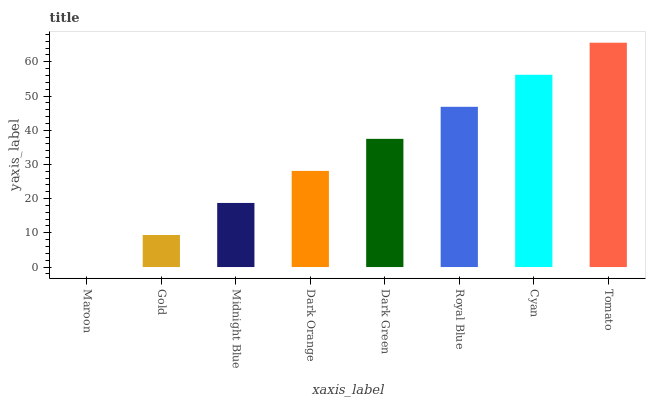Is Maroon the minimum?
Answer yes or no. Yes. Is Tomato the maximum?
Answer yes or no. Yes. Is Gold the minimum?
Answer yes or no. No. Is Gold the maximum?
Answer yes or no. No. Is Gold greater than Maroon?
Answer yes or no. Yes. Is Maroon less than Gold?
Answer yes or no. Yes. Is Maroon greater than Gold?
Answer yes or no. No. Is Gold less than Maroon?
Answer yes or no. No. Is Dark Green the high median?
Answer yes or no. Yes. Is Dark Orange the low median?
Answer yes or no. Yes. Is Cyan the high median?
Answer yes or no. No. Is Cyan the low median?
Answer yes or no. No. 